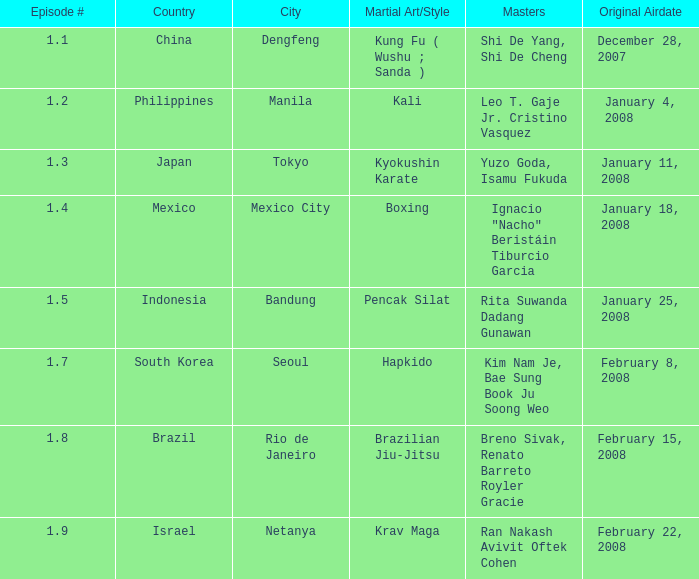How many masters fought using a boxing style? 1.0. Could you parse the entire table? {'header': ['Episode #', 'Country', 'City', 'Martial Art/Style', 'Masters', 'Original Airdate'], 'rows': [['1.1', 'China', 'Dengfeng', 'Kung Fu ( Wushu ; Sanda )', 'Shi De Yang, Shi De Cheng', 'December 28, 2007'], ['1.2', 'Philippines', 'Manila', 'Kali', 'Leo T. Gaje Jr. Cristino Vasquez', 'January 4, 2008'], ['1.3', 'Japan', 'Tokyo', 'Kyokushin Karate', 'Yuzo Goda, Isamu Fukuda', 'January 11, 2008'], ['1.4', 'Mexico', 'Mexico City', 'Boxing', 'Ignacio "Nacho" Beristáin Tiburcio Garcia', 'January 18, 2008'], ['1.5', 'Indonesia', 'Bandung', 'Pencak Silat', 'Rita Suwanda Dadang Gunawan', 'January 25, 2008'], ['1.7', 'South Korea', 'Seoul', 'Hapkido', 'Kim Nam Je, Bae Sung Book Ju Soong Weo', 'February 8, 2008'], ['1.8', 'Brazil', 'Rio de Janeiro', 'Brazilian Jiu-Jitsu', 'Breno Sivak, Renato Barreto Royler Gracie', 'February 15, 2008'], ['1.9', 'Israel', 'Netanya', 'Krav Maga', 'Ran Nakash Avivit Oftek Cohen', 'February 22, 2008']]} 